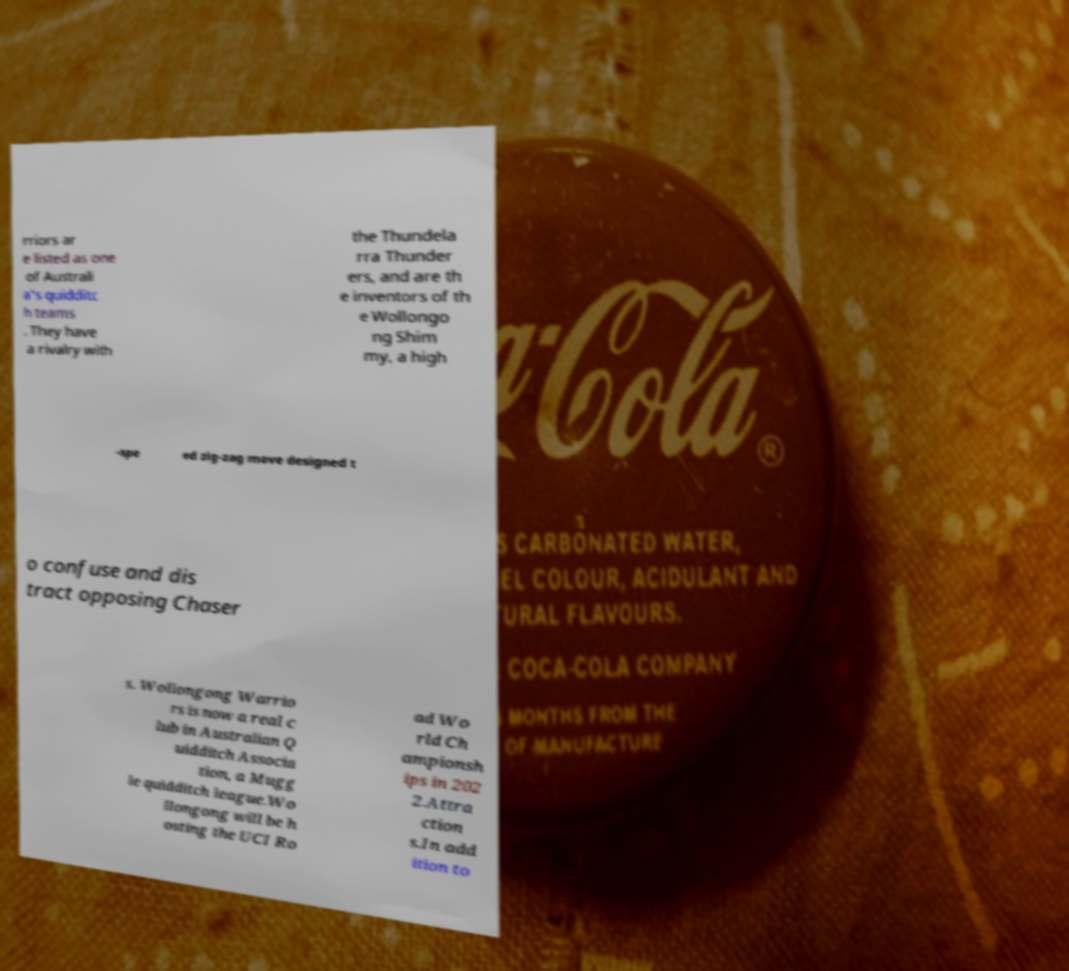I need the written content from this picture converted into text. Can you do that? rriors ar e listed as one of Australi a's quidditc h teams . They have a rivalry with the Thundela rra Thunder ers, and are th e inventors of th e Wollongo ng Shim my, a high -spe ed zig-zag move designed t o confuse and dis tract opposing Chaser s. Wollongong Warrio rs is now a real c lub in Australian Q uidditch Associa tion, a Mugg le quidditch league.Wo llongong will be h osting the UCI Ro ad Wo rld Ch ampionsh ips in 202 2.Attra ction s.In add ition to 